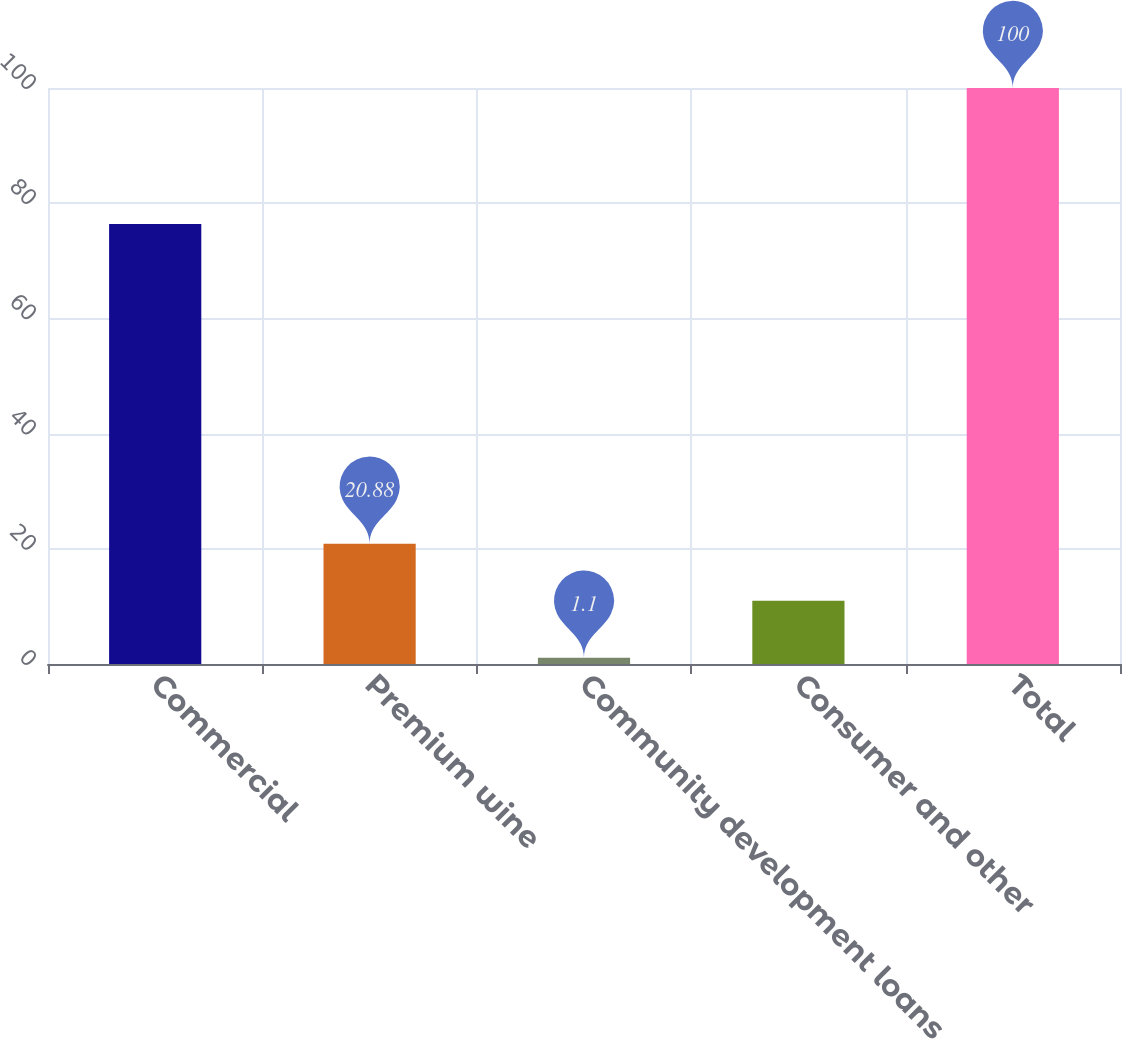<chart> <loc_0><loc_0><loc_500><loc_500><bar_chart><fcel>Commercial<fcel>Premium wine<fcel>Community development loans<fcel>Consumer and other<fcel>Total<nl><fcel>76.4<fcel>20.88<fcel>1.1<fcel>10.99<fcel>100<nl></chart> 